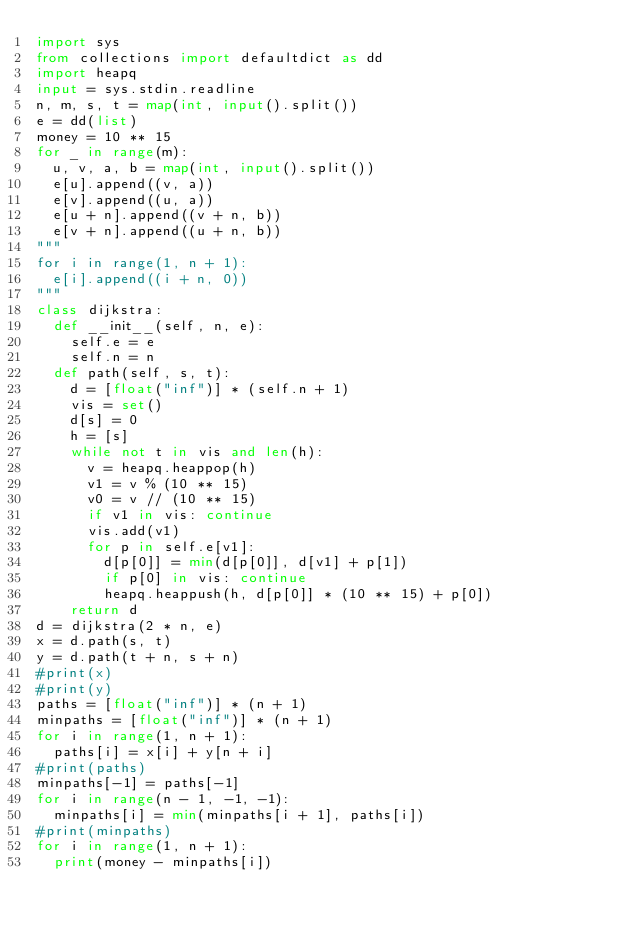Convert code to text. <code><loc_0><loc_0><loc_500><loc_500><_Python_>import sys
from collections import defaultdict as dd
import heapq
input = sys.stdin.readline
n, m, s, t = map(int, input().split())
e = dd(list)
money = 10 ** 15
for _ in range(m):
  u, v, a, b = map(int, input().split())
  e[u].append((v, a))
  e[v].append((u, a))
  e[u + n].append((v + n, b))
  e[v + n].append((u + n, b))
"""
for i in range(1, n + 1):
  e[i].append((i + n, 0))
"""
class dijkstra:
  def __init__(self, n, e):
    self.e = e
    self.n = n
  def path(self, s, t):
    d = [float("inf")] * (self.n + 1)
    vis = set()
    d[s] = 0
    h = [s]
    while not t in vis and len(h):
      v = heapq.heappop(h)
      v1 = v % (10 ** 15)
      v0 = v // (10 ** 15)
      if v1 in vis: continue
      vis.add(v1)
      for p in self.e[v1]:
        d[p[0]] = min(d[p[0]], d[v1] + p[1])
        if p[0] in vis: continue
        heapq.heappush(h, d[p[0]] * (10 ** 15) + p[0])
    return d
d = dijkstra(2 * n, e)
x = d.path(s, t)
y = d.path(t + n, s + n)
#print(x)
#print(y)
paths = [float("inf")] * (n + 1)
minpaths = [float("inf")] * (n + 1)
for i in range(1, n + 1):
  paths[i] = x[i] + y[n + i]
#print(paths)
minpaths[-1] = paths[-1]
for i in range(n - 1, -1, -1):
  minpaths[i] = min(minpaths[i + 1], paths[i])
#print(minpaths)
for i in range(1, n + 1):
  print(money - minpaths[i])</code> 